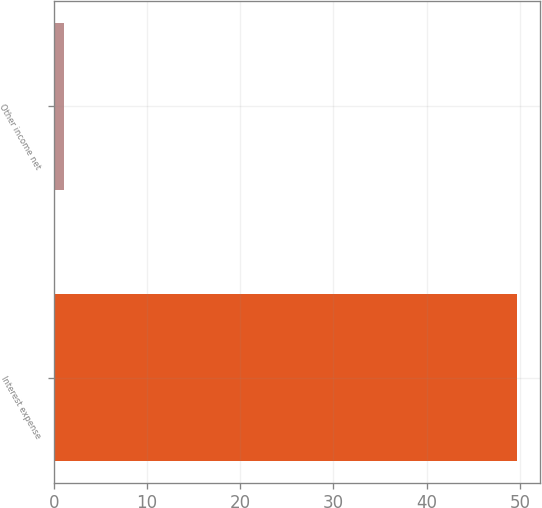Convert chart to OTSL. <chart><loc_0><loc_0><loc_500><loc_500><bar_chart><fcel>Interest expense<fcel>Other income net<nl><fcel>49.7<fcel>1.1<nl></chart> 